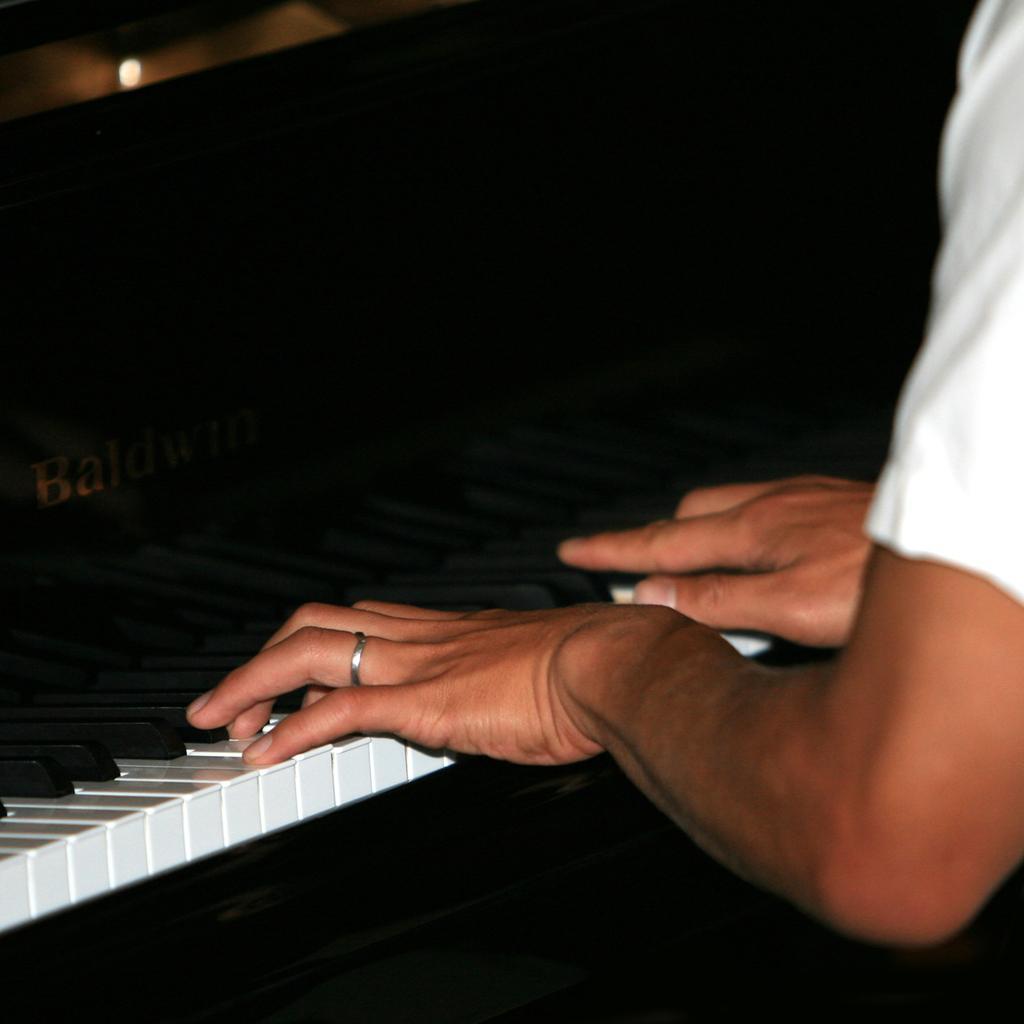Please provide a concise description of this image. In this picture I can see a person playing the piano, at the top there is a light. On the left side there is the name. 